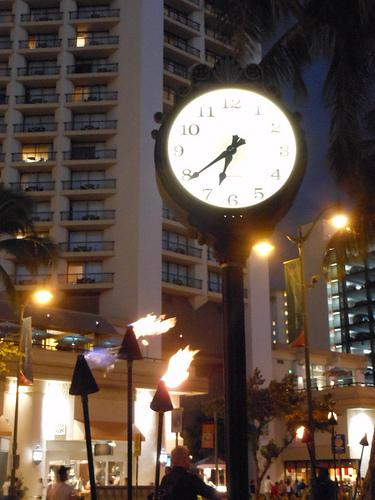Question: when is this taken?
Choices:
A. During the day time.
B. In the afternoon.
C. During night.
D. Around midnight.
Answer with the letter. Answer: C Question: what color is the post?
Choices:
A. Brown.
B. White.
C. Gray.
D. Black.
Answer with the letter. Answer: D Question: what does the man stand by?
Choices:
A. A clock.
B. The sign post.
C. The statue.
D. The palm tree.
Answer with the letter. Answer: A Question: where is the clock?
Choices:
A. On the wall.
B. On the desk.
C. On the bed.
D. On a pole.
Answer with the letter. Answer: D 